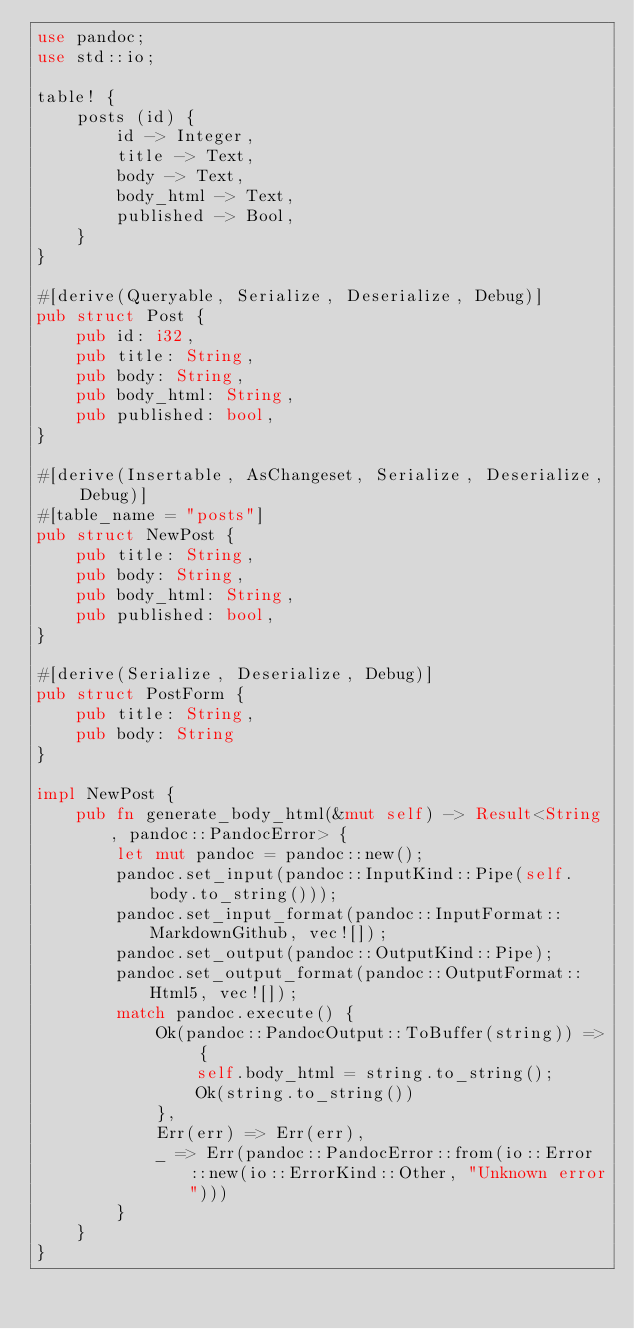Convert code to text. <code><loc_0><loc_0><loc_500><loc_500><_Rust_>use pandoc;
use std::io;

table! {
    posts (id) {
        id -> Integer,
        title -> Text,
        body -> Text,
        body_html -> Text,
        published -> Bool,
    }
}

#[derive(Queryable, Serialize, Deserialize, Debug)]
pub struct Post {
    pub id: i32,
    pub title: String,
    pub body: String,
    pub body_html: String,
    pub published: bool,
}

#[derive(Insertable, AsChangeset, Serialize, Deserialize, Debug)]
#[table_name = "posts"]
pub struct NewPost {
    pub title: String,
    pub body: String,
    pub body_html: String,
    pub published: bool,
}

#[derive(Serialize, Deserialize, Debug)]
pub struct PostForm {
    pub title: String,
    pub body: String
}

impl NewPost {
    pub fn generate_body_html(&mut self) -> Result<String, pandoc::PandocError> {
        let mut pandoc = pandoc::new();
        pandoc.set_input(pandoc::InputKind::Pipe(self.body.to_string()));
        pandoc.set_input_format(pandoc::InputFormat::MarkdownGithub, vec![]);
        pandoc.set_output(pandoc::OutputKind::Pipe);
        pandoc.set_output_format(pandoc::OutputFormat::Html5, vec![]);
        match pandoc.execute() {
            Ok(pandoc::PandocOutput::ToBuffer(string)) => {
                self.body_html = string.to_string();
                Ok(string.to_string())
            },
            Err(err) => Err(err),
            _ => Err(pandoc::PandocError::from(io::Error::new(io::ErrorKind::Other, "Unknown error")))
        }
    }
}
</code> 